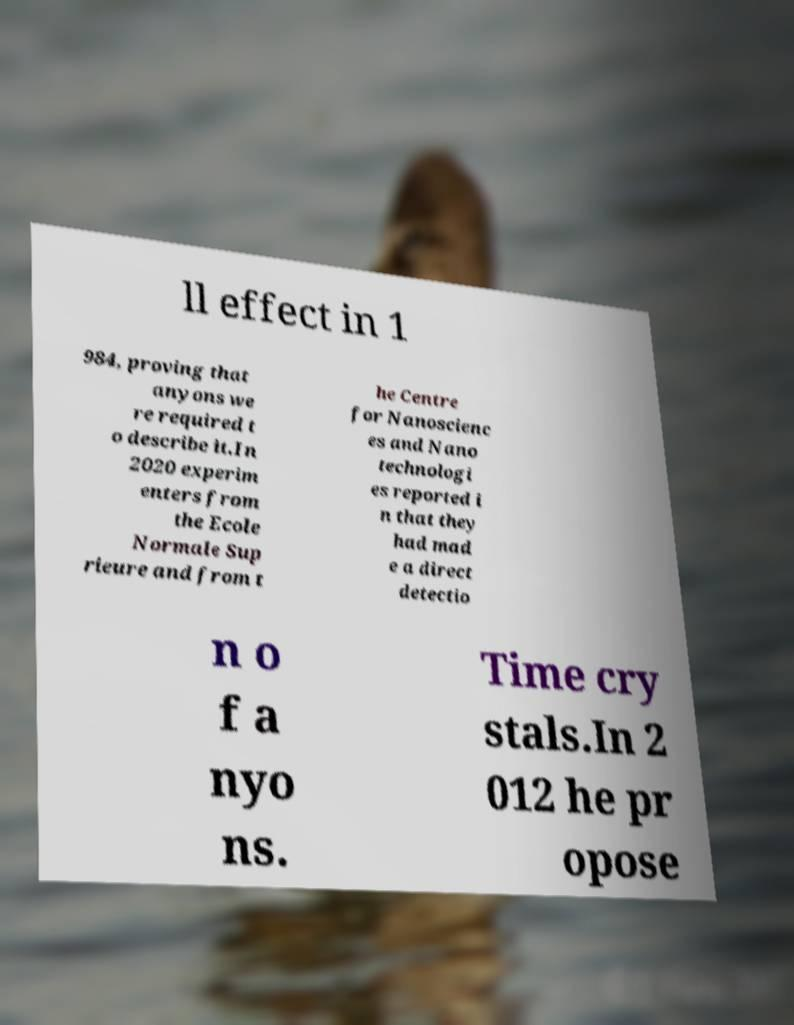Can you accurately transcribe the text from the provided image for me? ll effect in 1 984, proving that anyons we re required t o describe it.In 2020 experim enters from the Ecole Normale Sup rieure and from t he Centre for Nanoscienc es and Nano technologi es reported i n that they had mad e a direct detectio n o f a nyo ns. Time cry stals.In 2 012 he pr opose 